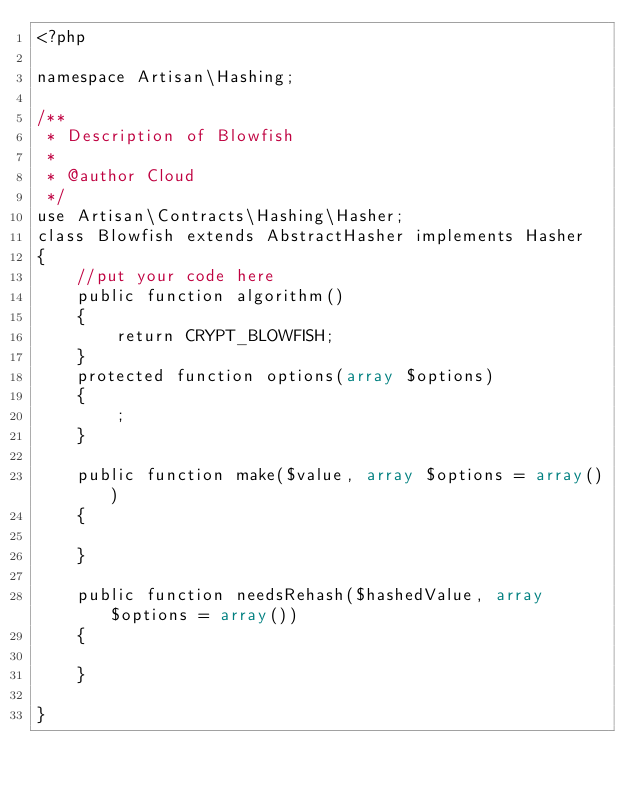<code> <loc_0><loc_0><loc_500><loc_500><_PHP_><?php

namespace Artisan\Hashing;

/**
 * Description of Blowfish
 *
 * @author Cloud
 */
use Artisan\Contracts\Hashing\Hasher;
class Blowfish extends AbstractHasher implements Hasher
{
    //put your code here
    public function algorithm()
    {
        return CRYPT_BLOWFISH;
    }
    protected function options(array $options)
    {
        ;
    }

    public function make($value, array $options = array())
    {
        
    }

    public function needsRehash($hashedValue, array $options = array())
    {
        
    }

}
</code> 